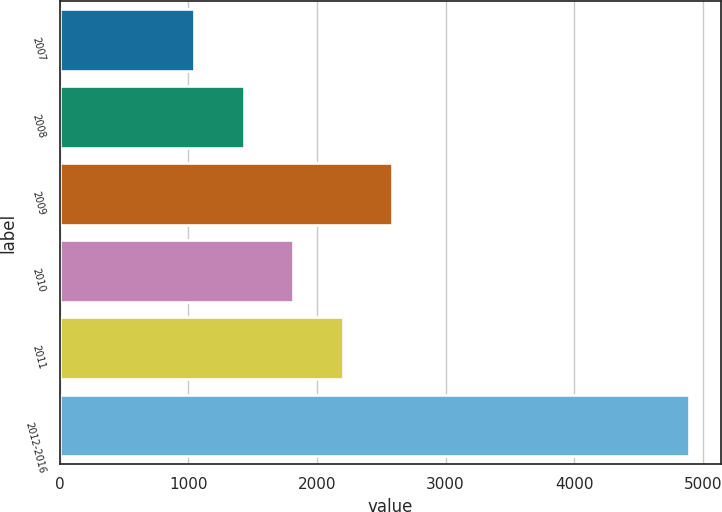Convert chart. <chart><loc_0><loc_0><loc_500><loc_500><bar_chart><fcel>2007<fcel>2008<fcel>2009<fcel>2010<fcel>2011<fcel>2012-2016<nl><fcel>1048<fcel>1432.5<fcel>2586<fcel>1817<fcel>2201.5<fcel>4893<nl></chart> 